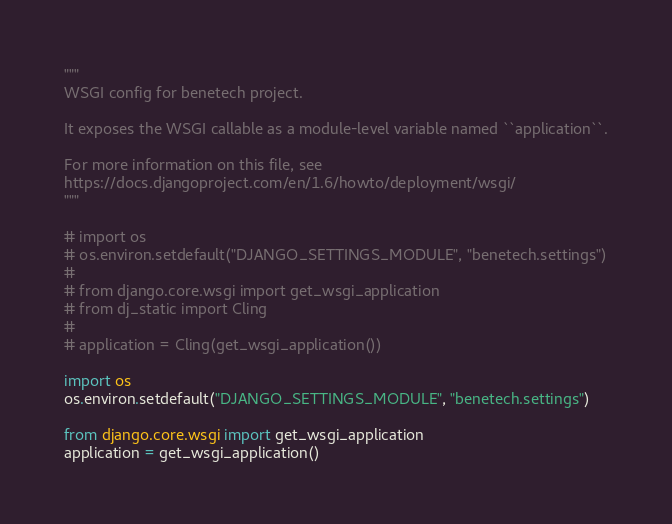Convert code to text. <code><loc_0><loc_0><loc_500><loc_500><_Python_>"""
WSGI config for benetech project.

It exposes the WSGI callable as a module-level variable named ``application``.

For more information on this file, see
https://docs.djangoproject.com/en/1.6/howto/deployment/wsgi/
"""

# import os
# os.environ.setdefault("DJANGO_SETTINGS_MODULE", "benetech.settings")
# 
# from django.core.wsgi import get_wsgi_application
# from dj_static import Cling
# 
# application = Cling(get_wsgi_application())

import os
os.environ.setdefault("DJANGO_SETTINGS_MODULE", "benetech.settings")

from django.core.wsgi import get_wsgi_application
application = get_wsgi_application()
</code> 